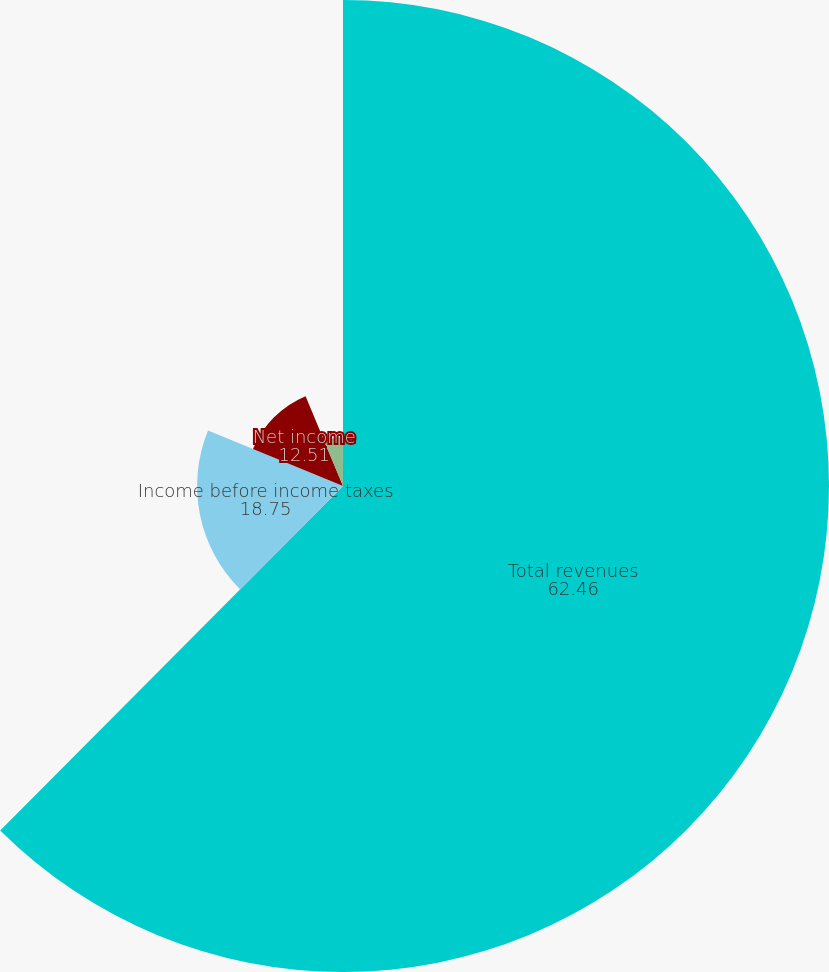Convert chart to OTSL. <chart><loc_0><loc_0><loc_500><loc_500><pie_chart><fcel>Total revenues<fcel>Income before income taxes<fcel>Net income<fcel>Basic earnings per common<fcel>Diluted earnings per common<nl><fcel>62.46%<fcel>18.75%<fcel>12.51%<fcel>6.26%<fcel>0.02%<nl></chart> 